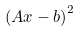<formula> <loc_0><loc_0><loc_500><loc_500>\left ( A x - b \right ) ^ { 2 }</formula> 